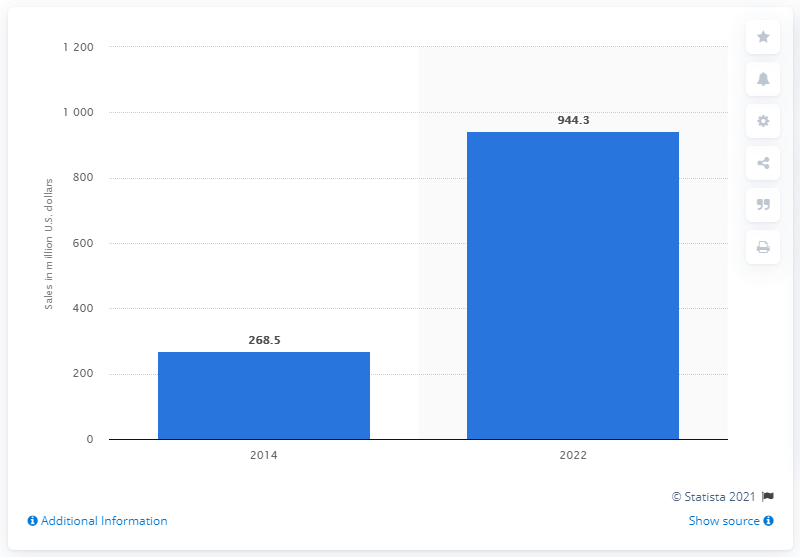Draw attention to some important aspects in this diagram. The estimated value of the global LiDAR market between 2014 and 2022 is approximately 944.3 million dollars. 